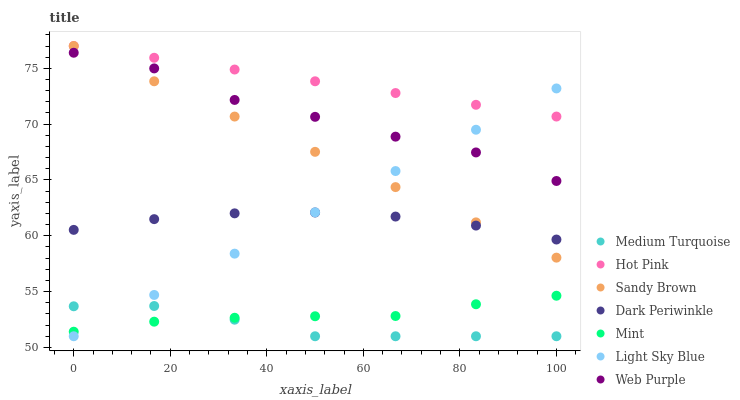Does Medium Turquoise have the minimum area under the curve?
Answer yes or no. Yes. Does Hot Pink have the maximum area under the curve?
Answer yes or no. Yes. Does Web Purple have the minimum area under the curve?
Answer yes or no. No. Does Web Purple have the maximum area under the curve?
Answer yes or no. No. Is Sandy Brown the smoothest?
Answer yes or no. Yes. Is Web Purple the roughest?
Answer yes or no. Yes. Is Hot Pink the smoothest?
Answer yes or no. No. Is Hot Pink the roughest?
Answer yes or no. No. Does Light Sky Blue have the lowest value?
Answer yes or no. Yes. Does Web Purple have the lowest value?
Answer yes or no. No. Does Hot Pink have the highest value?
Answer yes or no. Yes. Does Web Purple have the highest value?
Answer yes or no. No. Is Dark Periwinkle less than Hot Pink?
Answer yes or no. Yes. Is Sandy Brown greater than Mint?
Answer yes or no. Yes. Does Hot Pink intersect Light Sky Blue?
Answer yes or no. Yes. Is Hot Pink less than Light Sky Blue?
Answer yes or no. No. Is Hot Pink greater than Light Sky Blue?
Answer yes or no. No. Does Dark Periwinkle intersect Hot Pink?
Answer yes or no. No. 